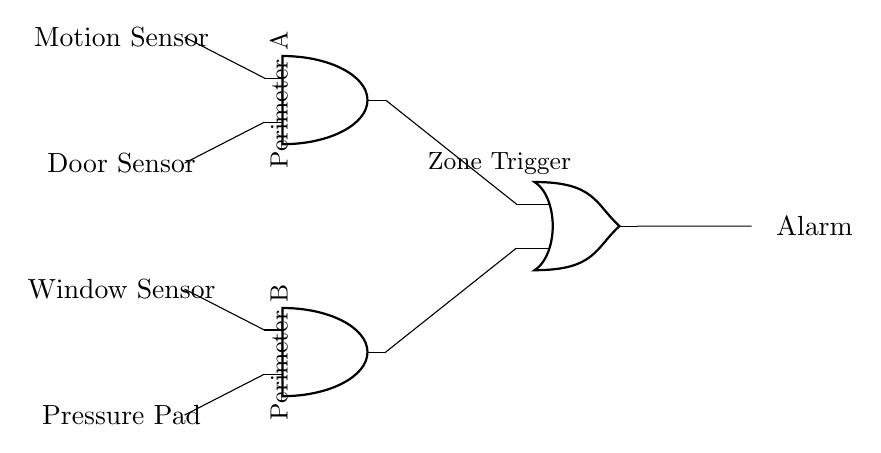What are the input sensors in this circuit? The circuit has four input sensors: Motion Sensor, Door Sensor, Window Sensor, and Pressure Pad. These are the initial points where the perimeter security system detects potential threats.
Answer: Motion Sensor, Door Sensor, Window Sensor, Pressure Pad What logical operation does the first AND gate perform? The first AND gate takes the input from the Motion Sensor and the Door Sensor. It outputs a signal only if both sensors are activated, indicating that there is activity detected at both points.
Answer: AND How many inputs does the second AND gate have? The second AND gate has two inputs as represented by the connections from the Window Sensor and the Pressure Pad. Both must be activated for the gate to output a signal.
Answer: Two inputs What is the overall function of the OR gate in this circuit? The OR gate receives inputs from the outputs of the two AND gates. It will output an alarm signal if either one of the AND gate outputs is active, signifying a breach in either perimeter A or B.
Answer: Alarm trigger How many distinct zones can trigger the alarm? There are two zones capable of triggering the alarm, as each AND gate corresponds to a separate perimeter (A and B). The OR gate consolidates these inputs to activate the alarm.
Answer: Two zones If both AND gates output signals, what happens at the OR gate? If both AND gates output signals, the OR gate will also output a signal indicating that a breach has occurred, which activates the alarm. This showcases the redundancy and reliability of the alarm system.
Answer: Alarm activates 